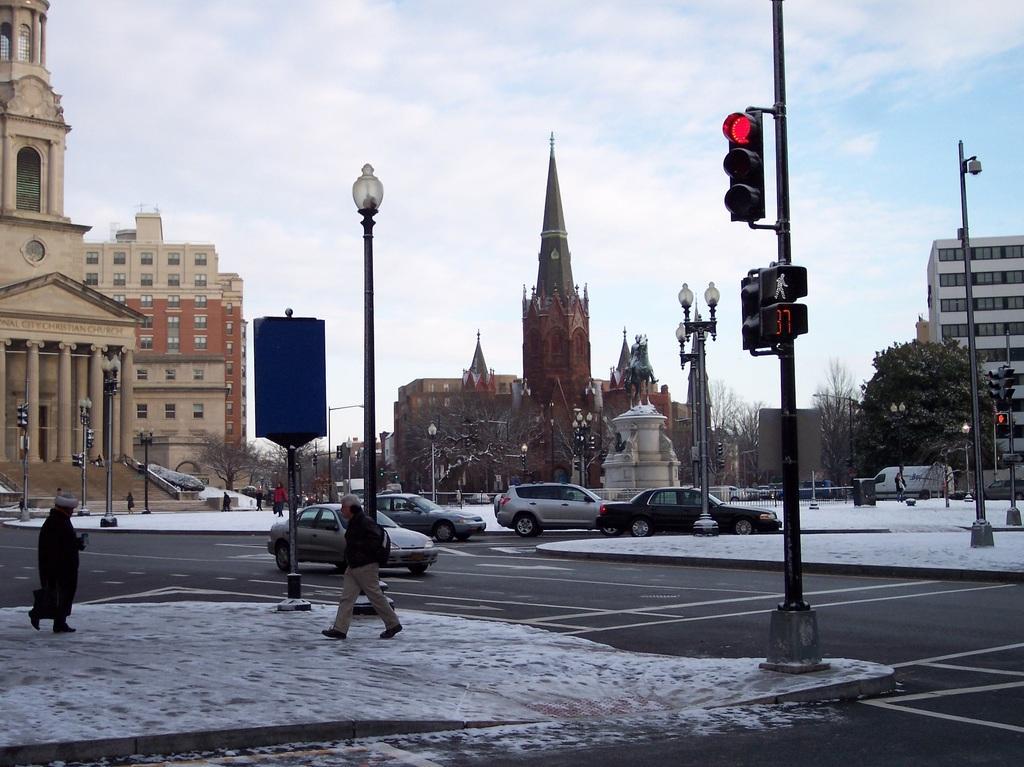Describe this image in one or two sentences. In this image we can see some buildings, a group of trees and a tower. We can also see a group of vehicles on the road, some people standing on the footpath, some street poles, the traffic signal, the signboards, a fence and the sky which looks cloudy. 